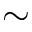<formula> <loc_0><loc_0><loc_500><loc_500>\sim</formula> 